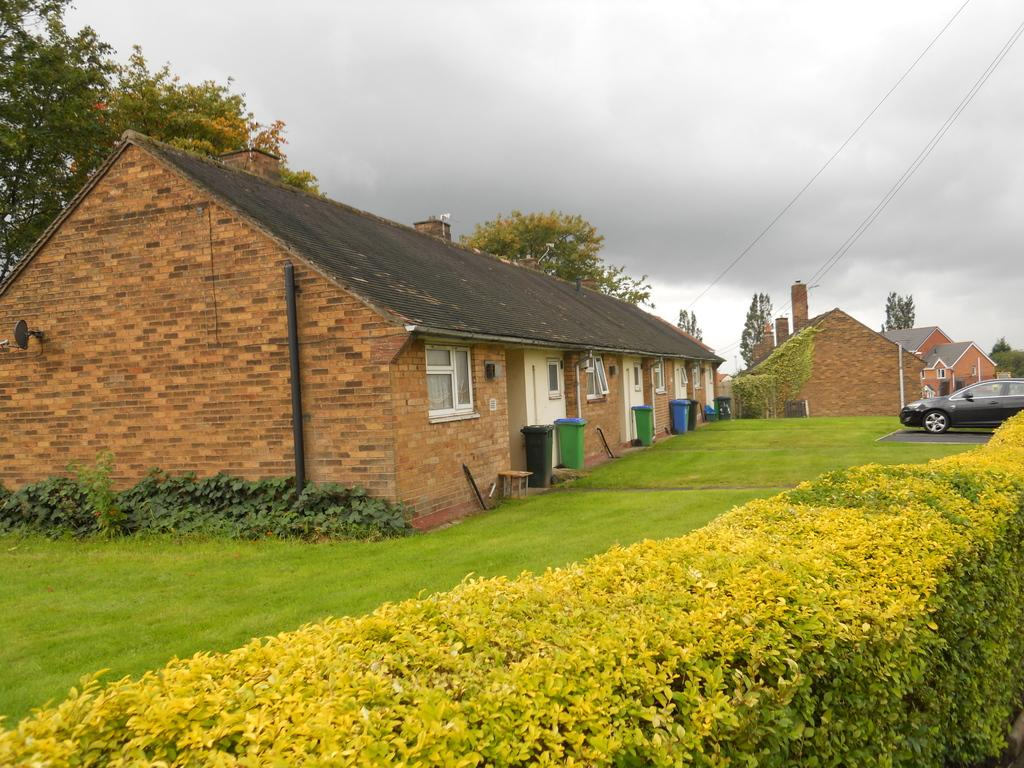What type of structures are located on the right side of the image? There are houses on the right side of the image. What can be seen in the center of the image? There are houses and a grassland in the center of the image. What type of vehicle is present on the right side of the image? There is a car on the right side of the image. What type of horn is visible on the grassland in the image? There is no horn present in the image; it features houses, a grassland, and a car. What color is the hair of the person driving the car in the image? There is no person or hair visible in the image; it only shows houses, a grassland, and a car. 